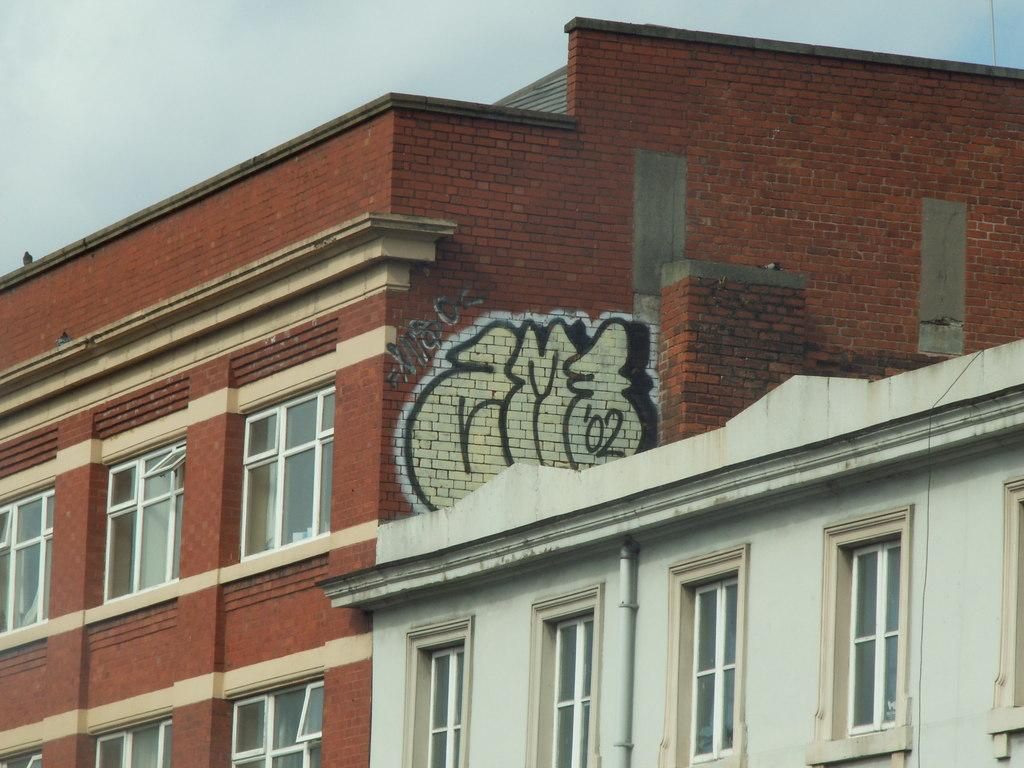What structures are located in the front of the image? There are buildings in the front of the image. What is the condition of the sky in the image? The sky is cloudy in the image. How many dogs can be seen in the image? There are no dogs present in the image. What time of day is depicted in the image? The time of day cannot be determined from the image, as there is no reference to the sun or any other time-related indicators. 